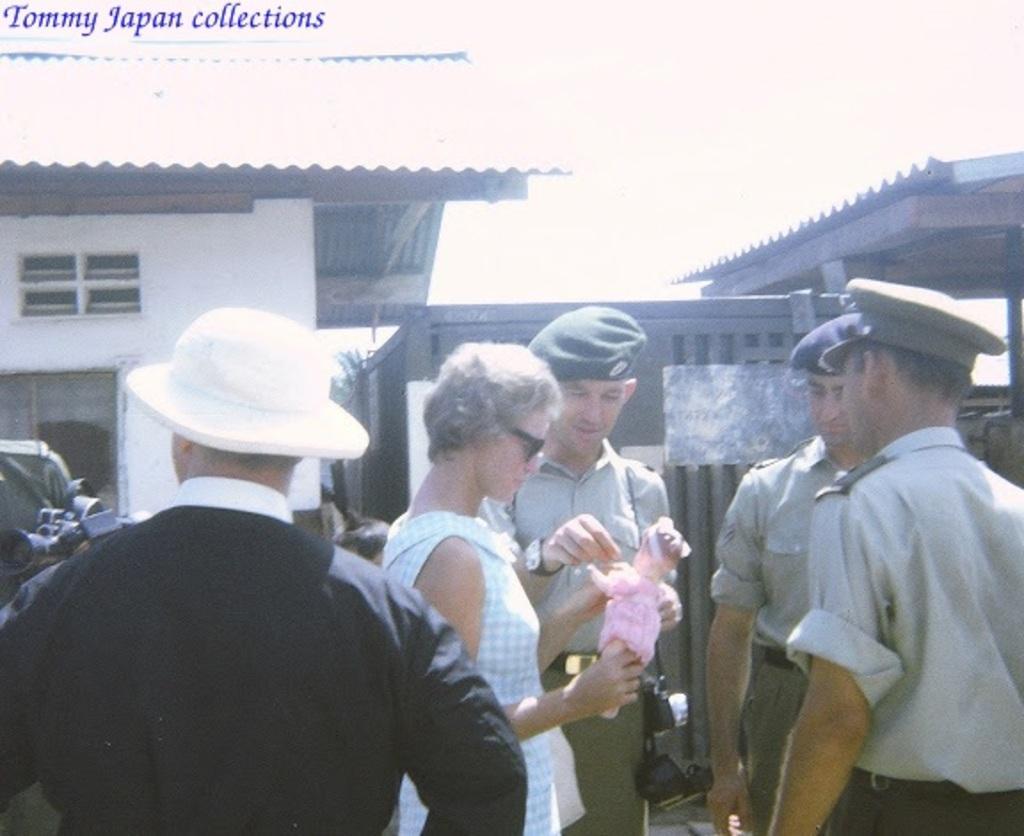Could you give a brief overview of what you see in this image? In this image, at the foreground I can see many people are standing, in the background, I can houses and some of them are wearing caps. 